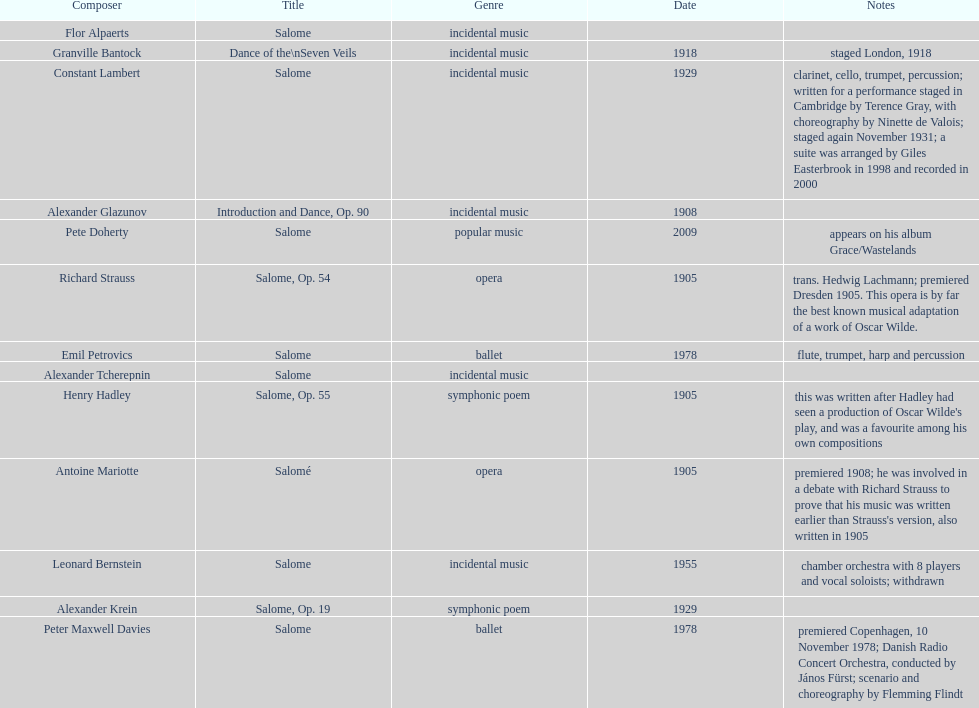Which composer produced his title after 2001? Pete Doherty. 